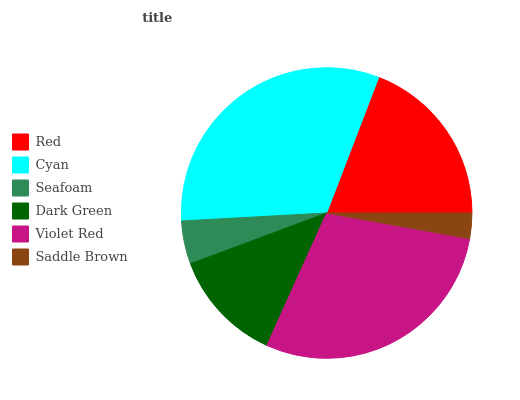Is Saddle Brown the minimum?
Answer yes or no. Yes. Is Cyan the maximum?
Answer yes or no. Yes. Is Seafoam the minimum?
Answer yes or no. No. Is Seafoam the maximum?
Answer yes or no. No. Is Cyan greater than Seafoam?
Answer yes or no. Yes. Is Seafoam less than Cyan?
Answer yes or no. Yes. Is Seafoam greater than Cyan?
Answer yes or no. No. Is Cyan less than Seafoam?
Answer yes or no. No. Is Red the high median?
Answer yes or no. Yes. Is Dark Green the low median?
Answer yes or no. Yes. Is Violet Red the high median?
Answer yes or no. No. Is Seafoam the low median?
Answer yes or no. No. 